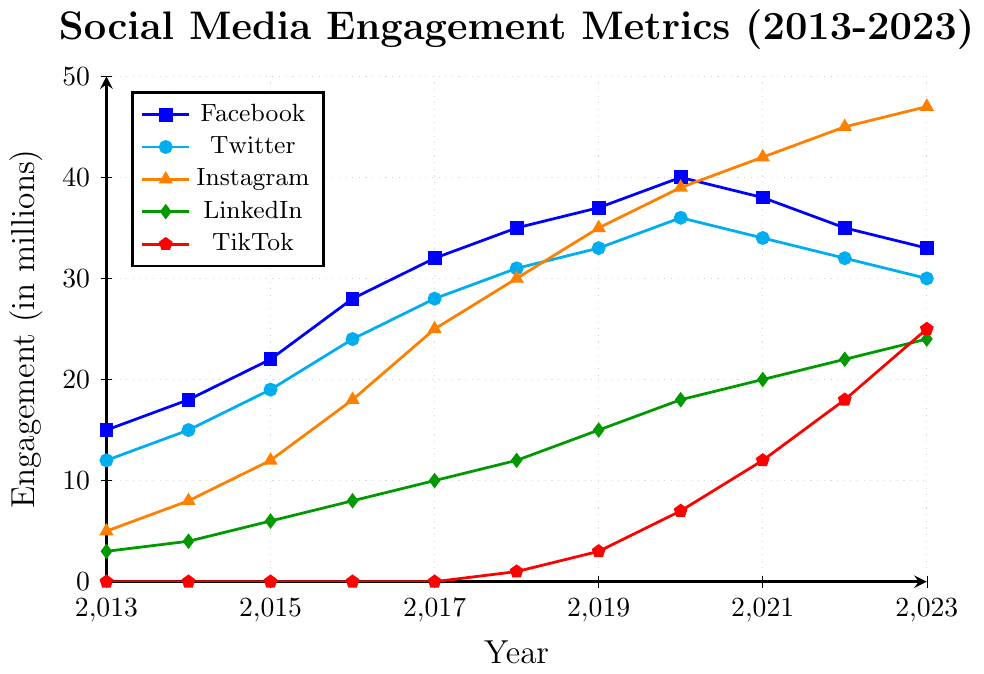How did TikTok's engagement grow from 2018 to 2023? TikTok's engagement starts at 1 million in 2018 and grows to 25 million by 2023. The difference is 25 - 1 = 24 million over the 5 years.
Answer: 24 million Which platform had the highest engagement in 2023? In 2023, Instagram has the highest engagement with 47 million.
Answer: Instagram Between which years did Facebook experience a decline in engagement? Facebook's engagement decreases between 2020 (40 million) and 2023 (33 million). The years where the decline is noticed are between 2020-2021, 2021-2022, and 2022-2023.
Answer: 2020-2021, 2021-2022, 2022-2023 Compare the engagement growth of Instagram and LinkedIn from 2013 to 2023. Which one grew more? Instagram's engagement grows from 5 million in 2013 to 47 million in 2023 (42 million growth). LinkedIn's engagement grows from 3 million in 2013 to 24 million in 2023 (21 million growth). Since 42 million is greater than 21 million, Instagram grew more.
Answer: Instagram What is the average engagement for Twitter over the entire period? Sum Twitter's engagement from 2013 to 2023: 12 + 15 + 19 + 24 + 28 + 31 + 33 + 36 + 34 + 32 + 30 = 294. There are 11 years, so the average is 294 / 11 ≈ 26.7 million.
Answer: 26.7 million In which year did Instagram's engagement surpass Facebook's engagement? In 2021, Instagram (42 million) surpasses Facebook (38 million).
Answer: 2021 Identify the three years when LinkedIn engagement increased the most year over year. Between 2018-2019 (12 to 15 million, 3 million increase), 2019-2020 (15 to 18 million, 3 million increase), and 2017-2018 (10 to 12 million, 2 million increase).
Answer: 2018-2019, 2019-2020, 2017-2018 What was the total combined engagement across all platforms in 2021? Sum the engagement for all platforms in 2021: Facebook 38 + Twitter 34 + Instagram 42 + LinkedIn 20 + TikTok 12 = 146 million.
Answer: 146 million How did LinkedIn's engagement in 2020 compare to its engagement in 2015? LinkedIn's engagement in 2020 is 18 million, while in 2015 it was 6 million. The increase is 18 - 6 = 12 million.
Answer: 12 million increase What was the trend of Twitter's engagement from 2019 to 2023? Twitter's engagement decreased from 2019 (33 million) to 2023 (30 million).
Answer: Decreasing 